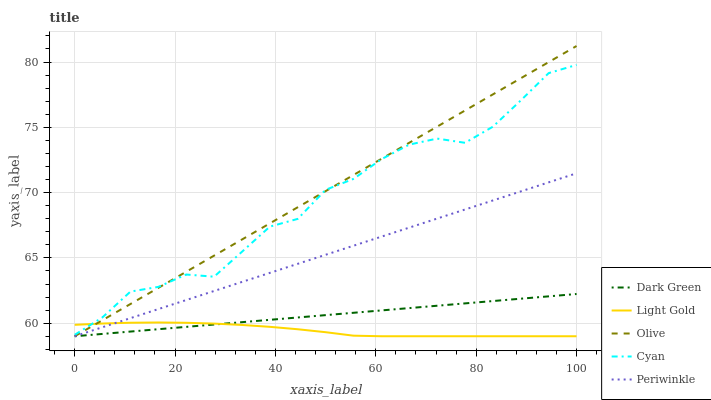Does Cyan have the minimum area under the curve?
Answer yes or no. No. Does Cyan have the maximum area under the curve?
Answer yes or no. No. Is Periwinkle the smoothest?
Answer yes or no. No. Is Periwinkle the roughest?
Answer yes or no. No. Does Cyan have the lowest value?
Answer yes or no. No. Does Cyan have the highest value?
Answer yes or no. No. Is Dark Green less than Cyan?
Answer yes or no. Yes. Is Cyan greater than Dark Green?
Answer yes or no. Yes. Does Dark Green intersect Cyan?
Answer yes or no. No. 